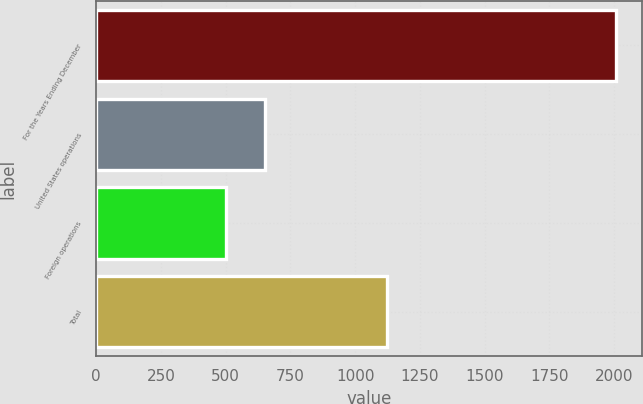Convert chart. <chart><loc_0><loc_0><loc_500><loc_500><bar_chart><fcel>For the Years Ending December<fcel>United States operations<fcel>Foreign operations<fcel>Total<nl><fcel>2008<fcel>653.5<fcel>503<fcel>1121.8<nl></chart> 